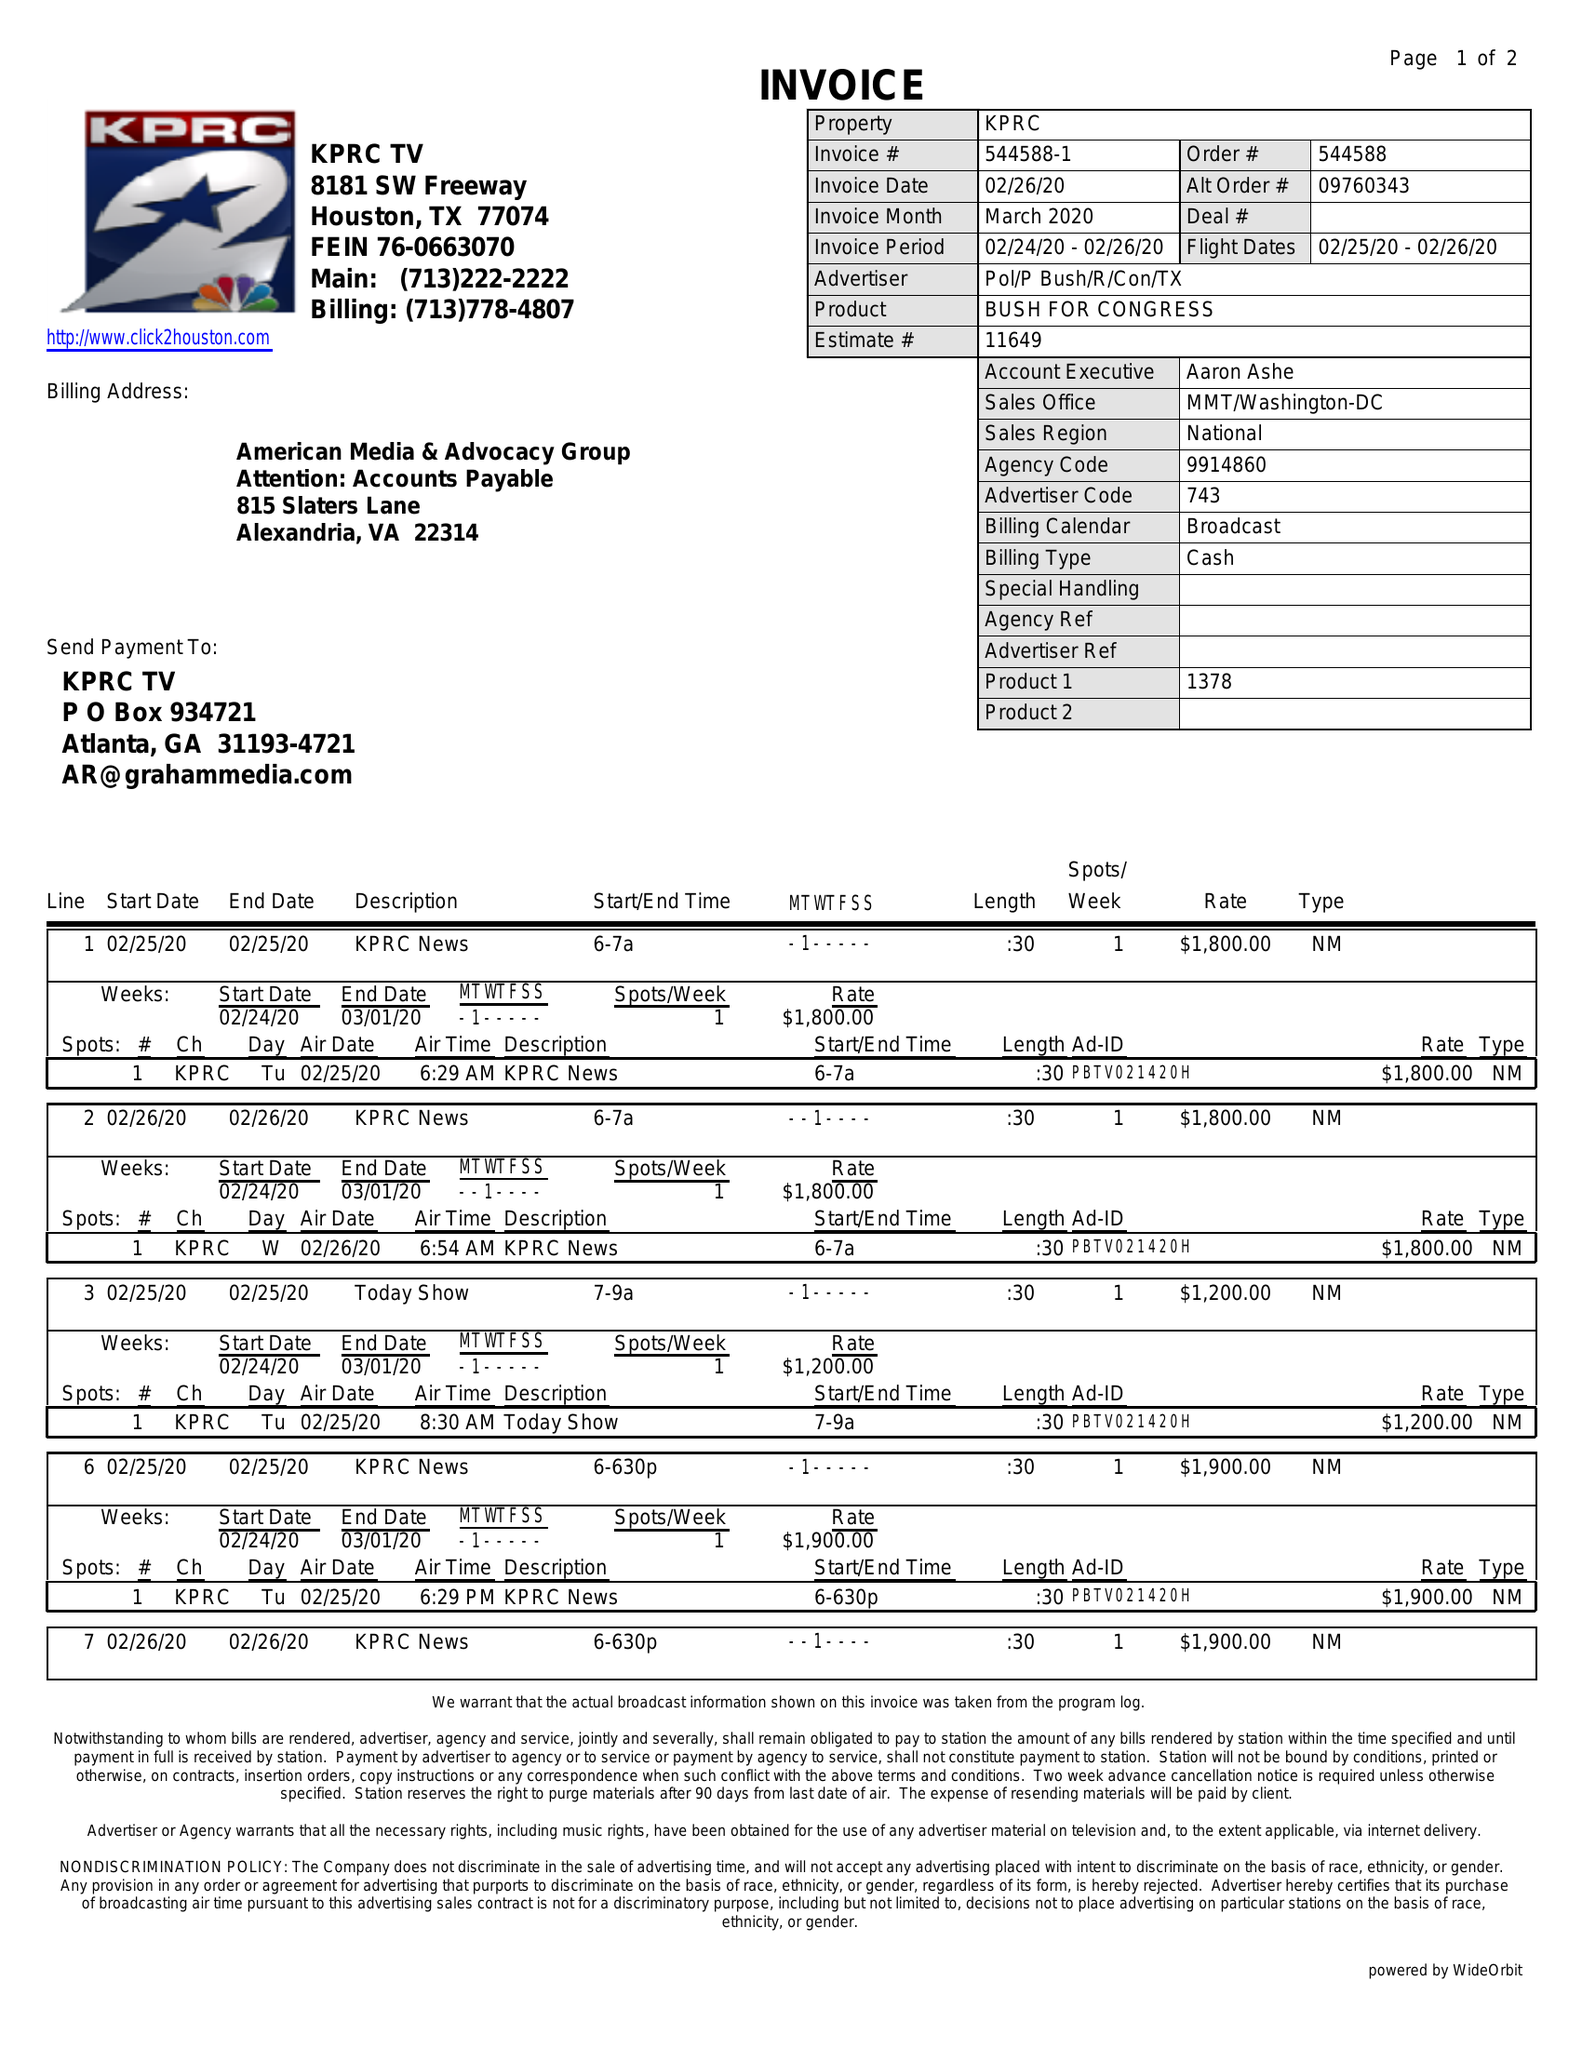What is the value for the flight_to?
Answer the question using a single word or phrase. 02/26/20 